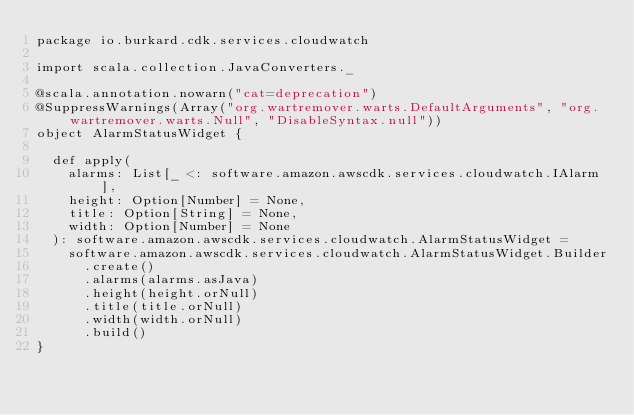Convert code to text. <code><loc_0><loc_0><loc_500><loc_500><_Scala_>package io.burkard.cdk.services.cloudwatch

import scala.collection.JavaConverters._

@scala.annotation.nowarn("cat=deprecation")
@SuppressWarnings(Array("org.wartremover.warts.DefaultArguments", "org.wartremover.warts.Null", "DisableSyntax.null"))
object AlarmStatusWidget {

  def apply(
    alarms: List[_ <: software.amazon.awscdk.services.cloudwatch.IAlarm],
    height: Option[Number] = None,
    title: Option[String] = None,
    width: Option[Number] = None
  ): software.amazon.awscdk.services.cloudwatch.AlarmStatusWidget =
    software.amazon.awscdk.services.cloudwatch.AlarmStatusWidget.Builder
      .create()
      .alarms(alarms.asJava)
      .height(height.orNull)
      .title(title.orNull)
      .width(width.orNull)
      .build()
}
</code> 